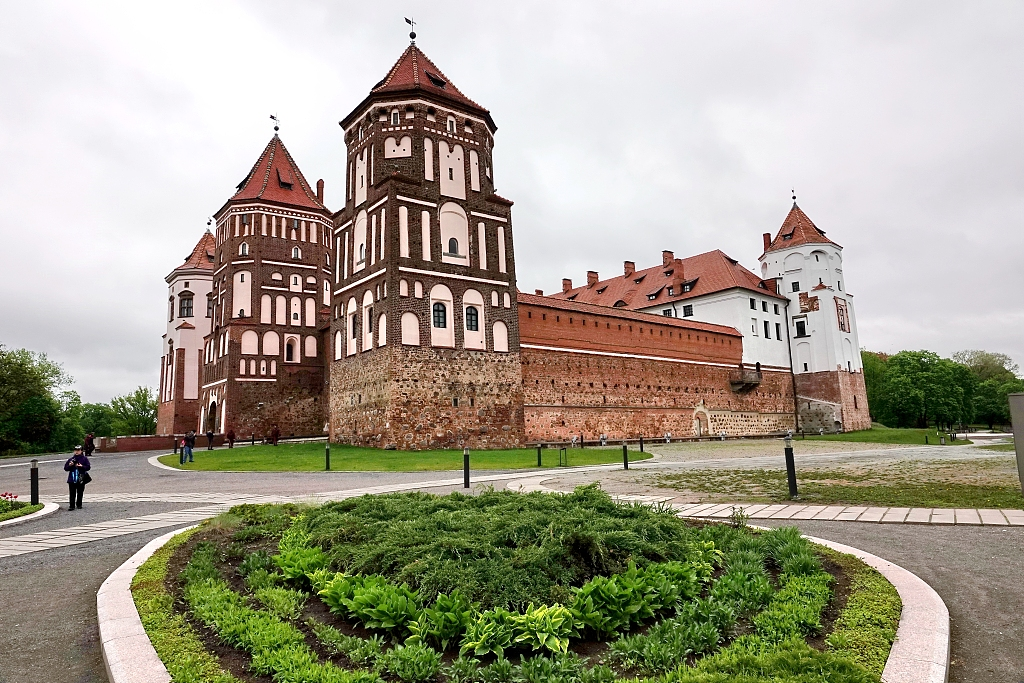What is this photo about'? This photo showcases the majestic Mir Castle Complex, a prominent 16th-century fortification situated in Belarus. Constructed from striking red bricks, the castle stands in grandeur against a cloudy sky. Its notable towers, particularly one with a pointed roof, contribute to its imposing and historic presence. From this perspective, we can appreciate both the impressive architecture and the surrounding landscape, including a meticulously maintained garden and a welcoming path leading to the castle’s entrance. Despite the overcast conditions, the photograph powerfully conveys the historical significance and architectural splendor of this renowned landmark. 